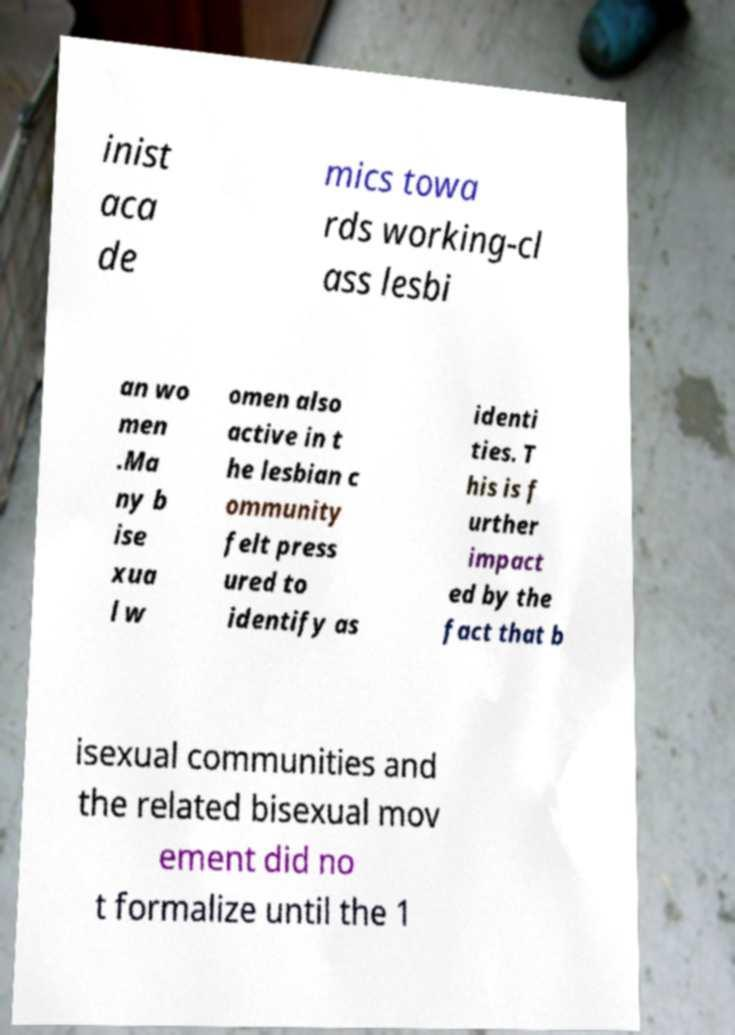Can you accurately transcribe the text from the provided image for me? inist aca de mics towa rds working-cl ass lesbi an wo men .Ma ny b ise xua l w omen also active in t he lesbian c ommunity felt press ured to identify as identi ties. T his is f urther impact ed by the fact that b isexual communities and the related bisexual mov ement did no t formalize until the 1 